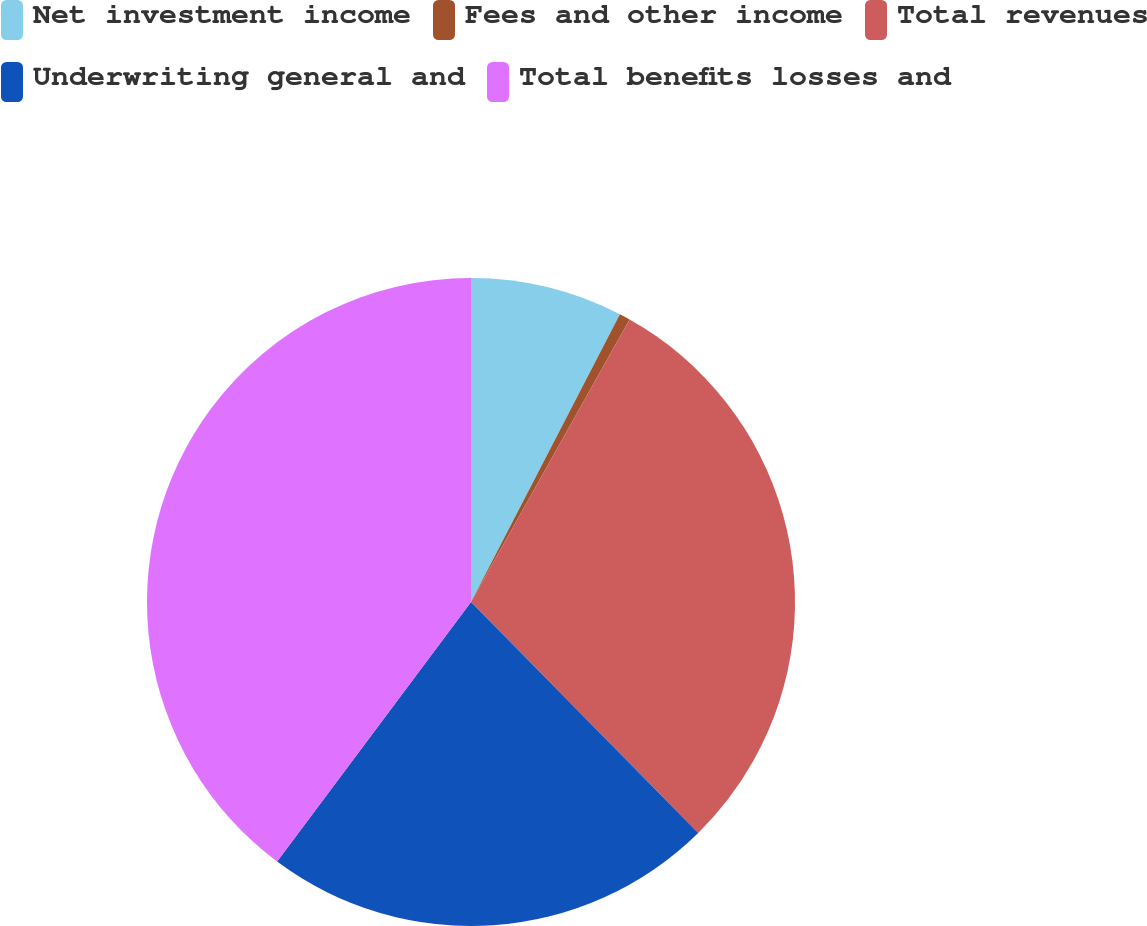Convert chart. <chart><loc_0><loc_0><loc_500><loc_500><pie_chart><fcel>Net investment income<fcel>Fees and other income<fcel>Total revenues<fcel>Underwriting general and<fcel>Total benefits losses and<nl><fcel>7.6%<fcel>0.54%<fcel>29.49%<fcel>22.58%<fcel>39.79%<nl></chart> 